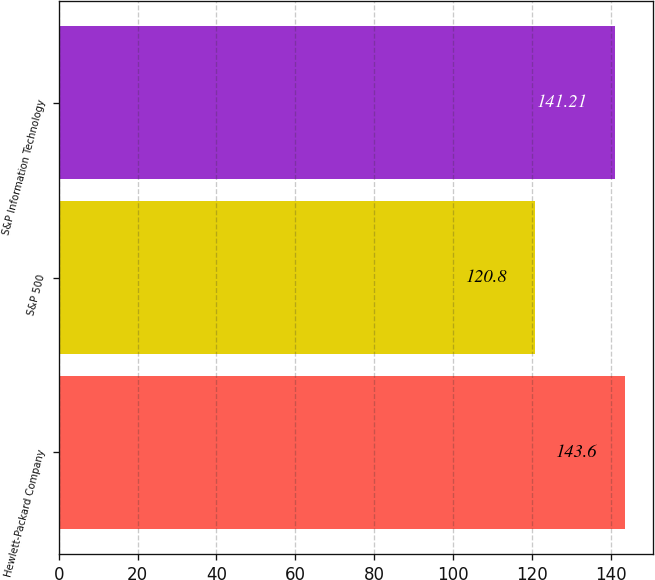Convert chart. <chart><loc_0><loc_0><loc_500><loc_500><bar_chart><fcel>Hewlett-Packard Company<fcel>S&P 500<fcel>S&P Information Technology<nl><fcel>143.6<fcel>120.8<fcel>141.21<nl></chart> 